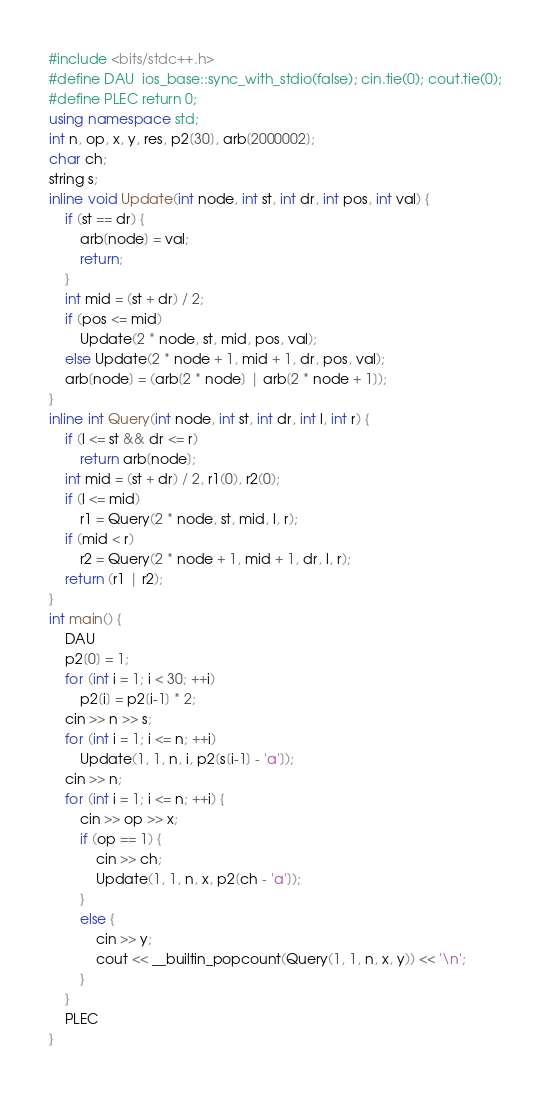<code> <loc_0><loc_0><loc_500><loc_500><_C++_>#include <bits/stdc++.h>
#define DAU  ios_base::sync_with_stdio(false); cin.tie(0); cout.tie(0);
#define PLEC return 0;
using namespace std;
int n, op, x, y, res, p2[30], arb[2000002];
char ch;
string s;
inline void Update(int node, int st, int dr, int pos, int val) {
    if (st == dr) {
        arb[node] = val;
        return;
    }
    int mid = (st + dr) / 2;
    if (pos <= mid)
        Update(2 * node, st, mid, pos, val);
    else Update(2 * node + 1, mid + 1, dr, pos, val);
    arb[node] = (arb[2 * node] | arb[2 * node + 1]);
}
inline int Query(int node, int st, int dr, int l, int r) {
    if (l <= st && dr <= r)
        return arb[node];
    int mid = (st + dr) / 2, r1(0), r2(0);
    if (l <= mid)
        r1 = Query(2 * node, st, mid, l, r);
    if (mid < r)
        r2 = Query(2 * node + 1, mid + 1, dr, l, r);
    return (r1 | r2);
}
int main() {
    DAU
    p2[0] = 1;
    for (int i = 1; i < 30; ++i)
        p2[i] = p2[i-1] * 2;
    cin >> n >> s;
    for (int i = 1; i <= n; ++i)
        Update(1, 1, n, i, p2[s[i-1] - 'a']);
    cin >> n;
    for (int i = 1; i <= n; ++i) {
        cin >> op >> x;
        if (op == 1) {
            cin >> ch;
            Update(1, 1, n, x, p2[ch - 'a']);
        }
        else {
            cin >> y;
            cout << __builtin_popcount(Query(1, 1, n, x, y)) << '\n';
        }
    }
    PLEC
}
</code> 